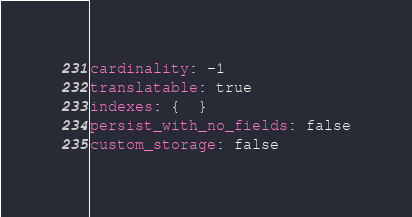Convert code to text. <code><loc_0><loc_0><loc_500><loc_500><_YAML_>cardinality: -1
translatable: true
indexes: {  }
persist_with_no_fields: false
custom_storage: false
</code> 